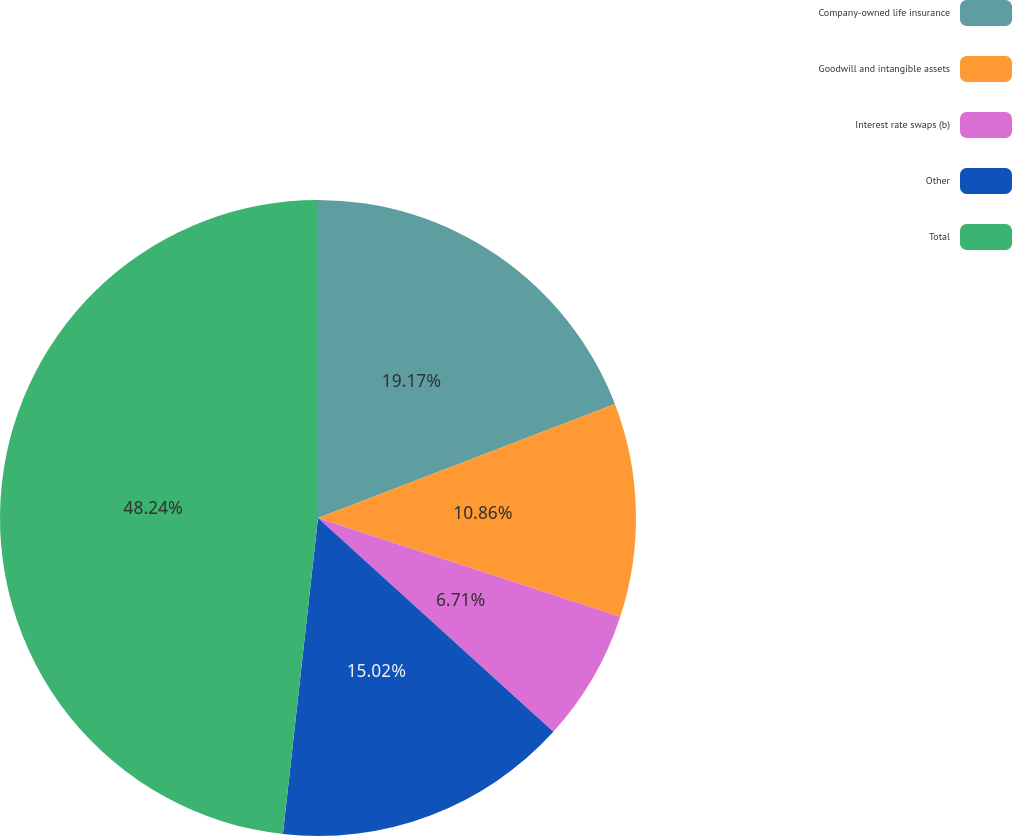Convert chart. <chart><loc_0><loc_0><loc_500><loc_500><pie_chart><fcel>Company-owned life insurance<fcel>Goodwill and intangible assets<fcel>Interest rate swaps (b)<fcel>Other<fcel>Total<nl><fcel>19.17%<fcel>10.86%<fcel>6.71%<fcel>15.02%<fcel>48.24%<nl></chart> 